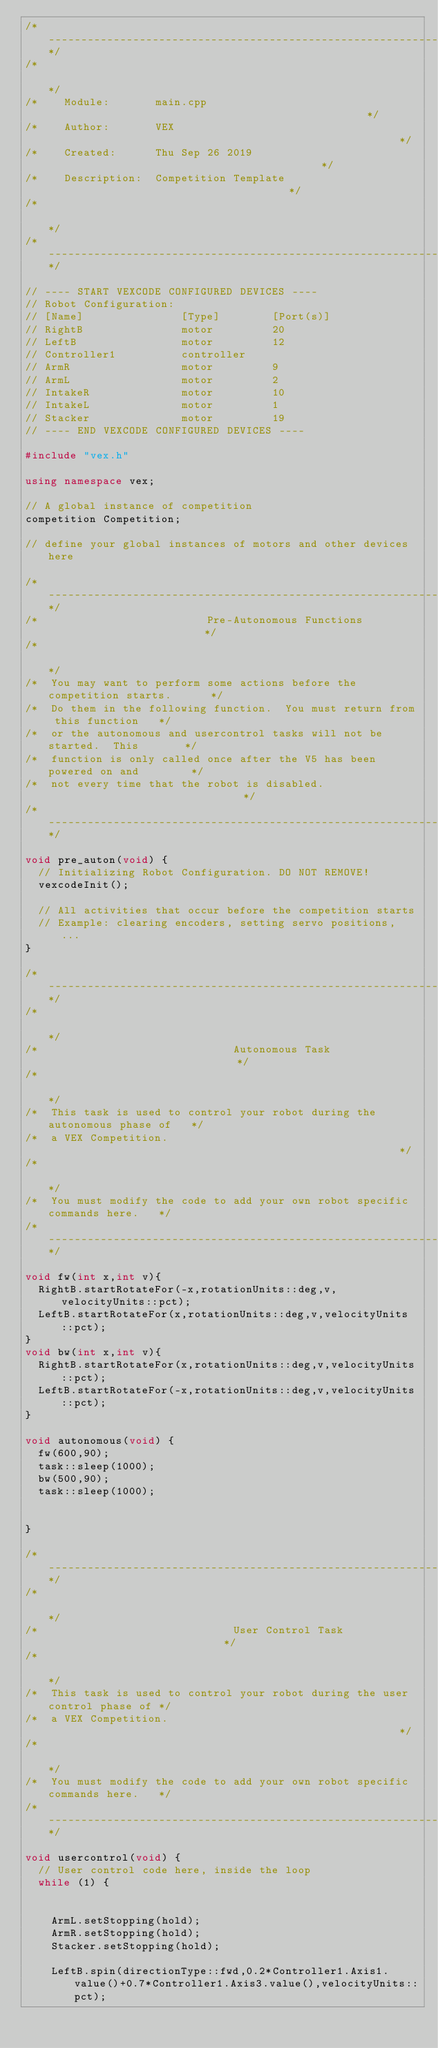Convert code to text. <code><loc_0><loc_0><loc_500><loc_500><_C++_>/*----------------------------------------------------------------------------*/
/*                                                                            */
/*    Module:       main.cpp                                                  */
/*    Author:       VEX                                                       */
/*    Created:      Thu Sep 26 2019                                           */
/*    Description:  Competition Template                                      */
/*                                                                            */
/*----------------------------------------------------------------------------*/

// ---- START VEXCODE CONFIGURED DEVICES ----
// Robot Configuration:
// [Name]               [Type]        [Port(s)]
// RightB               motor         20              
// LeftB                motor         12              
// Controller1          controller                    
// ArmR                 motor         9               
// ArmL                 motor         2               
// IntakeR              motor         10              
// IntakeL              motor         1               
// Stacker              motor         19              
// ---- END VEXCODE CONFIGURED DEVICES ----

#include "vex.h"

using namespace vex;

// A global instance of competition
competition Competition;

// define your global instances of motors and other devices here

/*---------------------------------------------------------------------------*/
/*                          Pre-Autonomous Functions                         */
/*                                                                           */
/*  You may want to perform some actions before the competition starts.      */
/*  Do them in the following function.  You must return from this function   */
/*  or the autonomous and usercontrol tasks will not be started.  This       */
/*  function is only called once after the V5 has been powered on and        */
/*  not every time that the robot is disabled.                               */
/*---------------------------------------------------------------------------*/

void pre_auton(void) {
  // Initializing Robot Configuration. DO NOT REMOVE!
  vexcodeInit();
  
  // All activities that occur before the competition starts
  // Example: clearing encoders, setting servo positions, ...
}

/*---------------------------------------------------------------------------*/
/*                                                                           */
/*                              Autonomous Task                              */
/*                                                                           */
/*  This task is used to control your robot during the autonomous phase of   */
/*  a VEX Competition.                                                       */
/*                                                                           */
/*  You must modify the code to add your own robot specific commands here.   */
/*---------------------------------------------------------------------------*/

void fw(int x,int v){
  RightB.startRotateFor(-x,rotationUnits::deg,v,velocityUnits::pct);
  LeftB.startRotateFor(x,rotationUnits::deg,v,velocityUnits::pct);
}
void bw(int x,int v){
  RightB.startRotateFor(x,rotationUnits::deg,v,velocityUnits::pct);
  LeftB.startRotateFor(-x,rotationUnits::deg,v,velocityUnits::pct);
}

void autonomous(void) {
  fw(600,90);
  task::sleep(1000);
  bw(500,90);
  task::sleep(1000);

  
}

/*---------------------------------------------------------------------------*/
/*                                                                           */
/*                              User Control Task                            */
/*                                                                           */
/*  This task is used to control your robot during the user control phase of */
/*  a VEX Competition.                                                       */
/*                                                                           */
/*  You must modify the code to add your own robot specific commands here.   */
/*---------------------------------------------------------------------------*/

void usercontrol(void) {
  // User control code here, inside the loop
  while (1) {
    

    ArmL.setStopping(hold);
    ArmR.setStopping(hold);
    Stacker.setStopping(hold);
    
    LeftB.spin(directionType::fwd,0.2*Controller1.Axis1.value()+0.7*Controller1.Axis3.value(),velocityUnits::pct);</code> 